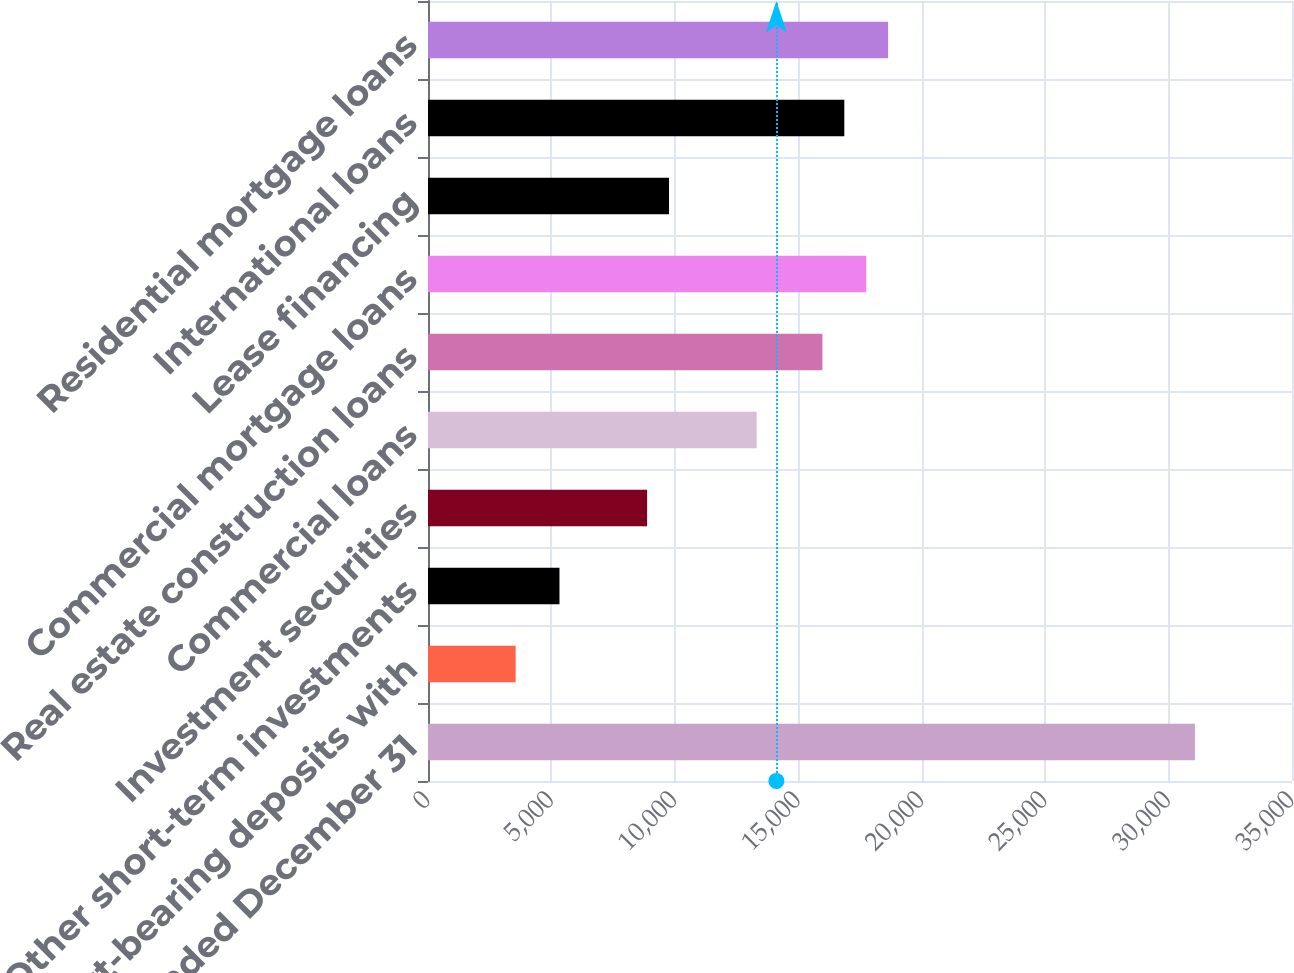Convert chart. <chart><loc_0><loc_0><loc_500><loc_500><bar_chart><fcel>Years Ended December 31<fcel>Interest-bearing deposits with<fcel>Other short-term investments<fcel>Investment securities<fcel>Commercial loans<fcel>Real estate construction loans<fcel>Commercial mortgage loans<fcel>Lease financing<fcel>International loans<fcel>Residential mortgage loans<nl><fcel>31066<fcel>3550.44<fcel>5325.64<fcel>8876.04<fcel>13314<fcel>15976.8<fcel>17752<fcel>9763.64<fcel>16864.4<fcel>18639.6<nl></chart> 